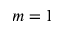Convert formula to latex. <formula><loc_0><loc_0><loc_500><loc_500>m = 1</formula> 